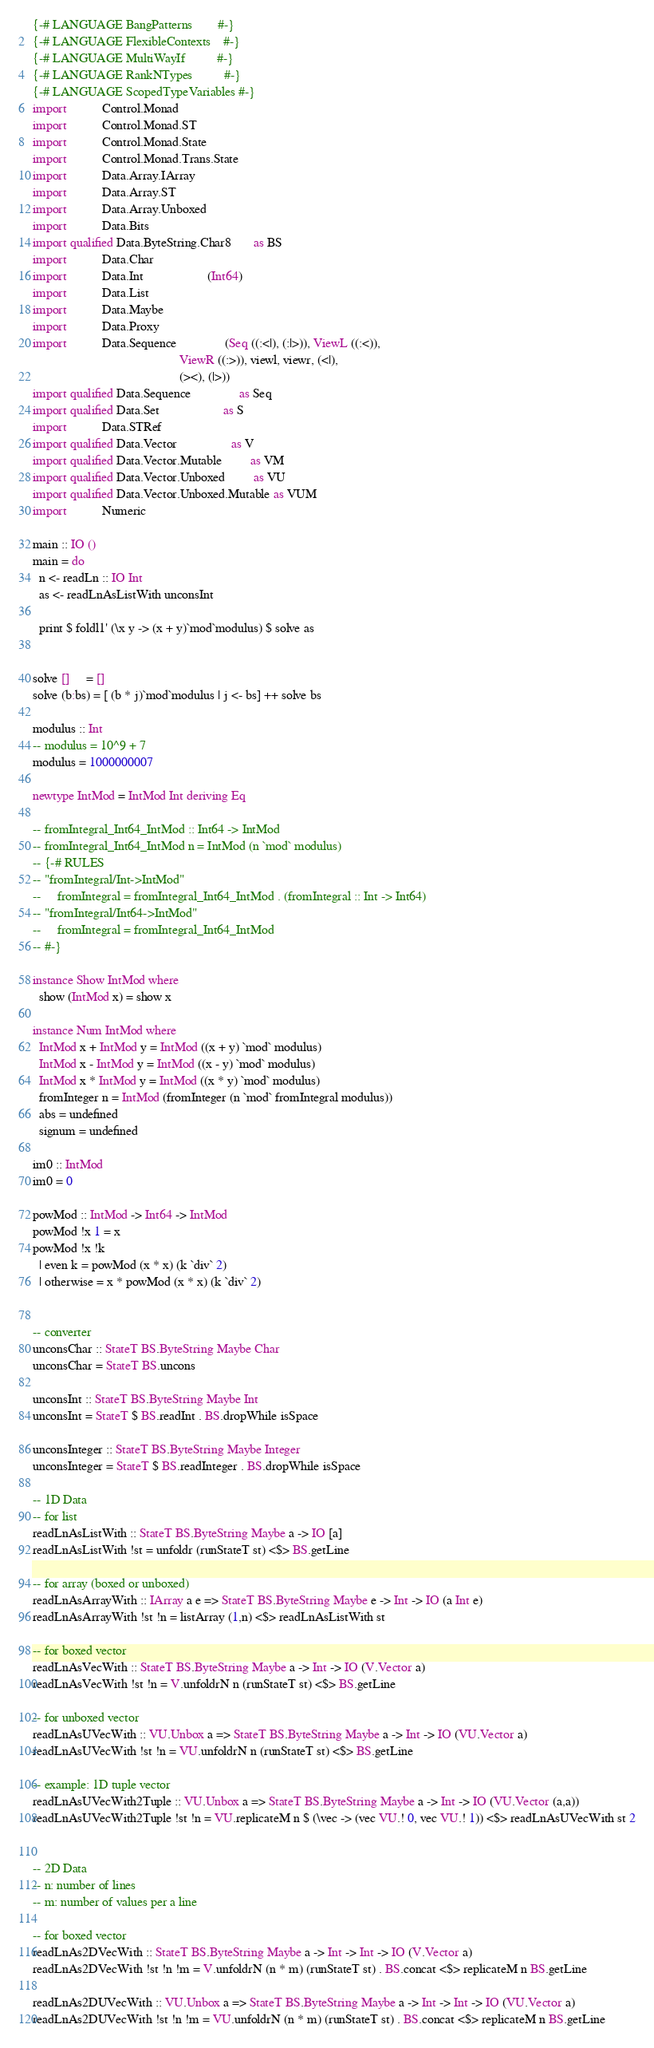Convert code to text. <code><loc_0><loc_0><loc_500><loc_500><_Haskell_>{-# LANGUAGE BangPatterns        #-}
{-# LANGUAGE FlexibleContexts    #-}
{-# LANGUAGE MultiWayIf          #-}
{-# LANGUAGE RankNTypes          #-}
{-# LANGUAGE ScopedTypeVariables #-}
import           Control.Monad
import           Control.Monad.ST
import           Control.Monad.State
import           Control.Monad.Trans.State
import           Data.Array.IArray
import           Data.Array.ST
import           Data.Array.Unboxed
import           Data.Bits
import qualified Data.ByteString.Char8       as BS
import           Data.Char
import           Data.Int                    (Int64)
import           Data.List
import           Data.Maybe
import           Data.Proxy
import           Data.Sequence               (Seq ((:<|), (:|>)), ViewL ((:<)),
                                              ViewR ((:>)), viewl, viewr, (<|),
                                              (><), (|>))
import qualified Data.Sequence               as Seq
import qualified Data.Set                    as S
import           Data.STRef
import qualified Data.Vector                 as V
import qualified Data.Vector.Mutable         as VM
import qualified Data.Vector.Unboxed         as VU
import qualified Data.Vector.Unboxed.Mutable as VUM
import           Numeric

main :: IO ()
main = do
  n <- readLn :: IO Int
  as <- readLnAsListWith unconsInt

  print $ foldl1' (\x y -> (x + y)`mod`modulus) $ solve as


solve []     = []
solve (b:bs) = [ (b * j)`mod`modulus | j <- bs] ++ solve bs

modulus :: Int
-- modulus = 10^9 + 7
modulus = 1000000007

newtype IntMod = IntMod Int deriving Eq

-- fromIntegral_Int64_IntMod :: Int64 -> IntMod
-- fromIntegral_Int64_IntMod n = IntMod (n `mod` modulus)
-- {-# RULES
-- "fromIntegral/Int->IntMod"
--     fromIntegral = fromIntegral_Int64_IntMod . (fromIntegral :: Int -> Int64)
-- "fromIntegral/Int64->IntMod"
--     fromIntegral = fromIntegral_Int64_IntMod
-- #-}

instance Show IntMod where
  show (IntMod x) = show x

instance Num IntMod where
  IntMod x + IntMod y = IntMod ((x + y) `mod` modulus)
  IntMod x - IntMod y = IntMod ((x - y) `mod` modulus)
  IntMod x * IntMod y = IntMod ((x * y) `mod` modulus)
  fromInteger n = IntMod (fromInteger (n `mod` fromIntegral modulus))
  abs = undefined
  signum = undefined

im0 :: IntMod
im0 = 0

powMod :: IntMod -> Int64 -> IntMod
powMod !x 1 = x
powMod !x !k
  | even k = powMod (x * x) (k `div` 2)
  | otherwise = x * powMod (x * x) (k `div` 2)


-- converter
unconsChar :: StateT BS.ByteString Maybe Char
unconsChar = StateT BS.uncons

unconsInt :: StateT BS.ByteString Maybe Int
unconsInt = StateT $ BS.readInt . BS.dropWhile isSpace

unconsInteger :: StateT BS.ByteString Maybe Integer
unconsInteger = StateT $ BS.readInteger . BS.dropWhile isSpace

-- 1D Data
-- for list
readLnAsListWith :: StateT BS.ByteString Maybe a -> IO [a]
readLnAsListWith !st = unfoldr (runStateT st) <$> BS.getLine

-- for array (boxed or unboxed)
readLnAsArrayWith :: IArray a e => StateT BS.ByteString Maybe e -> Int -> IO (a Int e)
readLnAsArrayWith !st !n = listArray (1,n) <$> readLnAsListWith st

-- for boxed vector
readLnAsVecWith :: StateT BS.ByteString Maybe a -> Int -> IO (V.Vector a)
readLnAsVecWith !st !n = V.unfoldrN n (runStateT st) <$> BS.getLine

-- for unboxed vector
readLnAsUVecWith :: VU.Unbox a => StateT BS.ByteString Maybe a -> Int -> IO (VU.Vector a)
readLnAsUVecWith !st !n = VU.unfoldrN n (runStateT st) <$> BS.getLine

-- example: 1D tuple vector
readLnAsUVecWith2Tuple :: VU.Unbox a => StateT BS.ByteString Maybe a -> Int -> IO (VU.Vector (a,a))
readLnAsUVecWith2Tuple !st !n = VU.replicateM n $ (\vec -> (vec VU.! 0, vec VU.! 1)) <$> readLnAsUVecWith st 2


-- 2D Data
-- n: number of lines
-- m: number of values per a line

-- for boxed vector
readLnAs2DVecWith :: StateT BS.ByteString Maybe a -> Int -> Int -> IO (V.Vector a)
readLnAs2DVecWith !st !n !m = V.unfoldrN (n * m) (runStateT st) . BS.concat <$> replicateM n BS.getLine

readLnAs2DUVecWith :: VU.Unbox a => StateT BS.ByteString Maybe a -> Int -> Int -> IO (VU.Vector a)
readLnAs2DUVecWith !st !n !m = VU.unfoldrN (n * m) (runStateT st) . BS.concat <$> replicateM n BS.getLine
</code> 